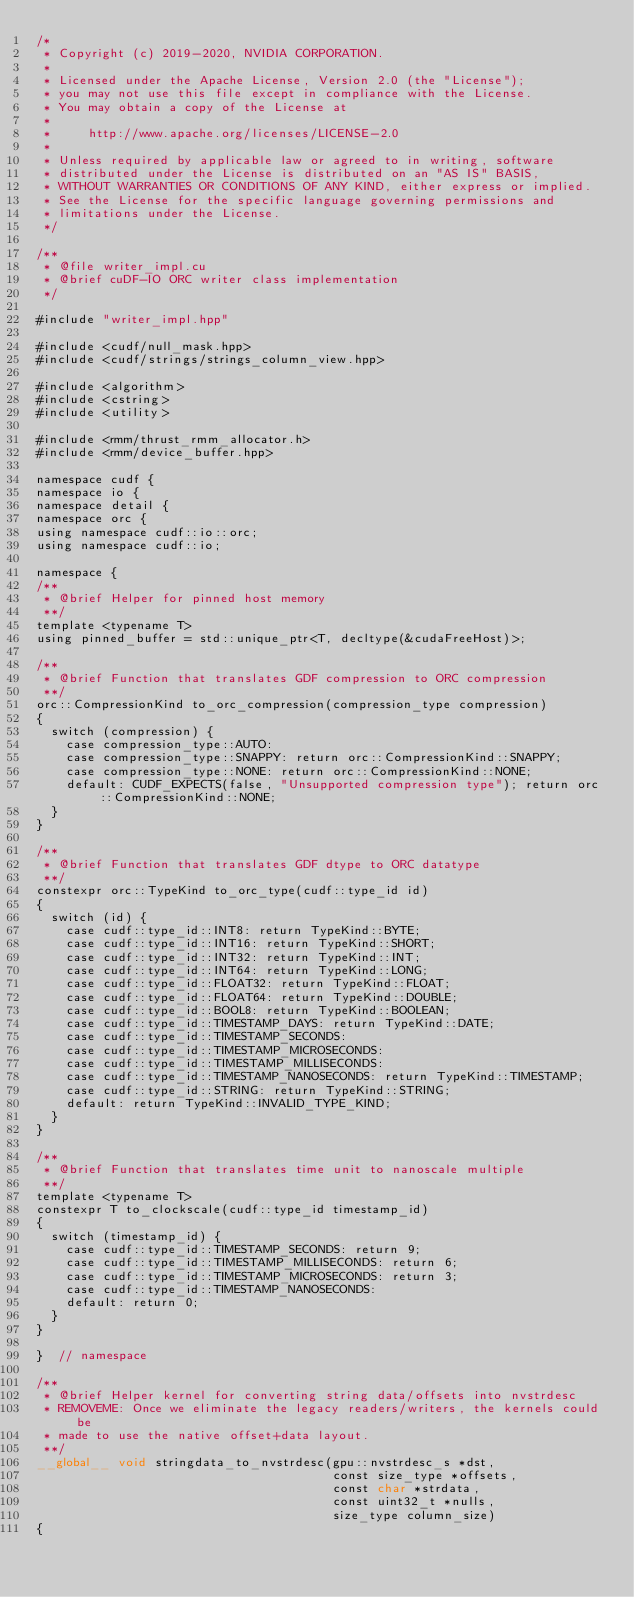Convert code to text. <code><loc_0><loc_0><loc_500><loc_500><_Cuda_>/*
 * Copyright (c) 2019-2020, NVIDIA CORPORATION.
 *
 * Licensed under the Apache License, Version 2.0 (the "License");
 * you may not use this file except in compliance with the License.
 * You may obtain a copy of the License at
 *
 *     http://www.apache.org/licenses/LICENSE-2.0
 *
 * Unless required by applicable law or agreed to in writing, software
 * distributed under the License is distributed on an "AS IS" BASIS,
 * WITHOUT WARRANTIES OR CONDITIONS OF ANY KIND, either express or implied.
 * See the License for the specific language governing permissions and
 * limitations under the License.
 */

/**
 * @file writer_impl.cu
 * @brief cuDF-IO ORC writer class implementation
 */

#include "writer_impl.hpp"

#include <cudf/null_mask.hpp>
#include <cudf/strings/strings_column_view.hpp>

#include <algorithm>
#include <cstring>
#include <utility>

#include <rmm/thrust_rmm_allocator.h>
#include <rmm/device_buffer.hpp>

namespace cudf {
namespace io {
namespace detail {
namespace orc {
using namespace cudf::io::orc;
using namespace cudf::io;

namespace {
/**
 * @brief Helper for pinned host memory
 **/
template <typename T>
using pinned_buffer = std::unique_ptr<T, decltype(&cudaFreeHost)>;

/**
 * @brief Function that translates GDF compression to ORC compression
 **/
orc::CompressionKind to_orc_compression(compression_type compression)
{
  switch (compression) {
    case compression_type::AUTO:
    case compression_type::SNAPPY: return orc::CompressionKind::SNAPPY;
    case compression_type::NONE: return orc::CompressionKind::NONE;
    default: CUDF_EXPECTS(false, "Unsupported compression type"); return orc::CompressionKind::NONE;
  }
}

/**
 * @brief Function that translates GDF dtype to ORC datatype
 **/
constexpr orc::TypeKind to_orc_type(cudf::type_id id)
{
  switch (id) {
    case cudf::type_id::INT8: return TypeKind::BYTE;
    case cudf::type_id::INT16: return TypeKind::SHORT;
    case cudf::type_id::INT32: return TypeKind::INT;
    case cudf::type_id::INT64: return TypeKind::LONG;
    case cudf::type_id::FLOAT32: return TypeKind::FLOAT;
    case cudf::type_id::FLOAT64: return TypeKind::DOUBLE;
    case cudf::type_id::BOOL8: return TypeKind::BOOLEAN;
    case cudf::type_id::TIMESTAMP_DAYS: return TypeKind::DATE;
    case cudf::type_id::TIMESTAMP_SECONDS:
    case cudf::type_id::TIMESTAMP_MICROSECONDS:
    case cudf::type_id::TIMESTAMP_MILLISECONDS:
    case cudf::type_id::TIMESTAMP_NANOSECONDS: return TypeKind::TIMESTAMP;
    case cudf::type_id::STRING: return TypeKind::STRING;
    default: return TypeKind::INVALID_TYPE_KIND;
  }
}

/**
 * @brief Function that translates time unit to nanoscale multiple
 **/
template <typename T>
constexpr T to_clockscale(cudf::type_id timestamp_id)
{
  switch (timestamp_id) {
    case cudf::type_id::TIMESTAMP_SECONDS: return 9;
    case cudf::type_id::TIMESTAMP_MILLISECONDS: return 6;
    case cudf::type_id::TIMESTAMP_MICROSECONDS: return 3;
    case cudf::type_id::TIMESTAMP_NANOSECONDS:
    default: return 0;
  }
}

}  // namespace

/**
 * @brief Helper kernel for converting string data/offsets into nvstrdesc
 * REMOVEME: Once we eliminate the legacy readers/writers, the kernels could be
 * made to use the native offset+data layout.
 **/
__global__ void stringdata_to_nvstrdesc(gpu::nvstrdesc_s *dst,
                                        const size_type *offsets,
                                        const char *strdata,
                                        const uint32_t *nulls,
                                        size_type column_size)
{</code> 